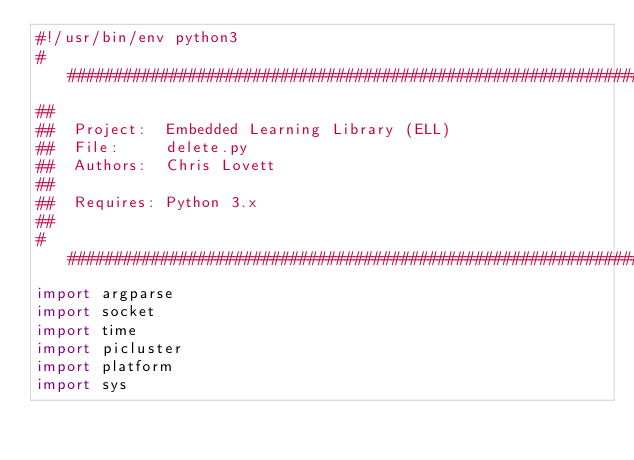<code> <loc_0><loc_0><loc_500><loc_500><_Python_>#!/usr/bin/env python3
###################################################################################################
##
##  Project:  Embedded Learning Library (ELL)
##  File:     delete.py
##  Authors:  Chris Lovett
##
##  Requires: Python 3.x
##
###################################################################################################
import argparse
import socket
import time
import picluster
import platform
import sys
</code> 